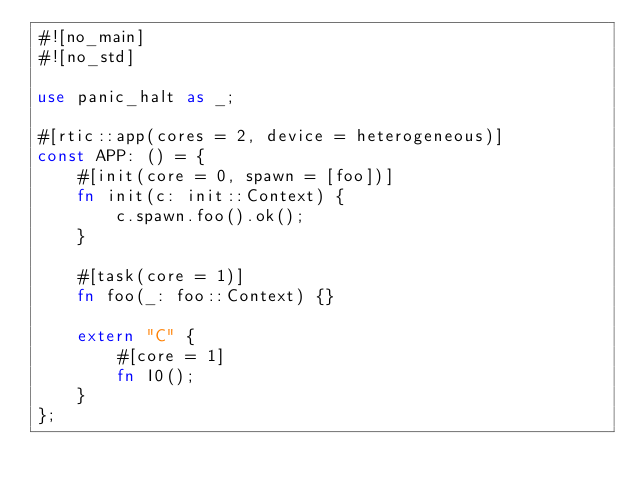<code> <loc_0><loc_0><loc_500><loc_500><_Rust_>#![no_main]
#![no_std]

use panic_halt as _;

#[rtic::app(cores = 2, device = heterogeneous)]
const APP: () = {
    #[init(core = 0, spawn = [foo])]
    fn init(c: init::Context) {
        c.spawn.foo().ok();
    }

    #[task(core = 1)]
    fn foo(_: foo::Context) {}

    extern "C" {
        #[core = 1]
        fn I0();
    }
};
</code> 